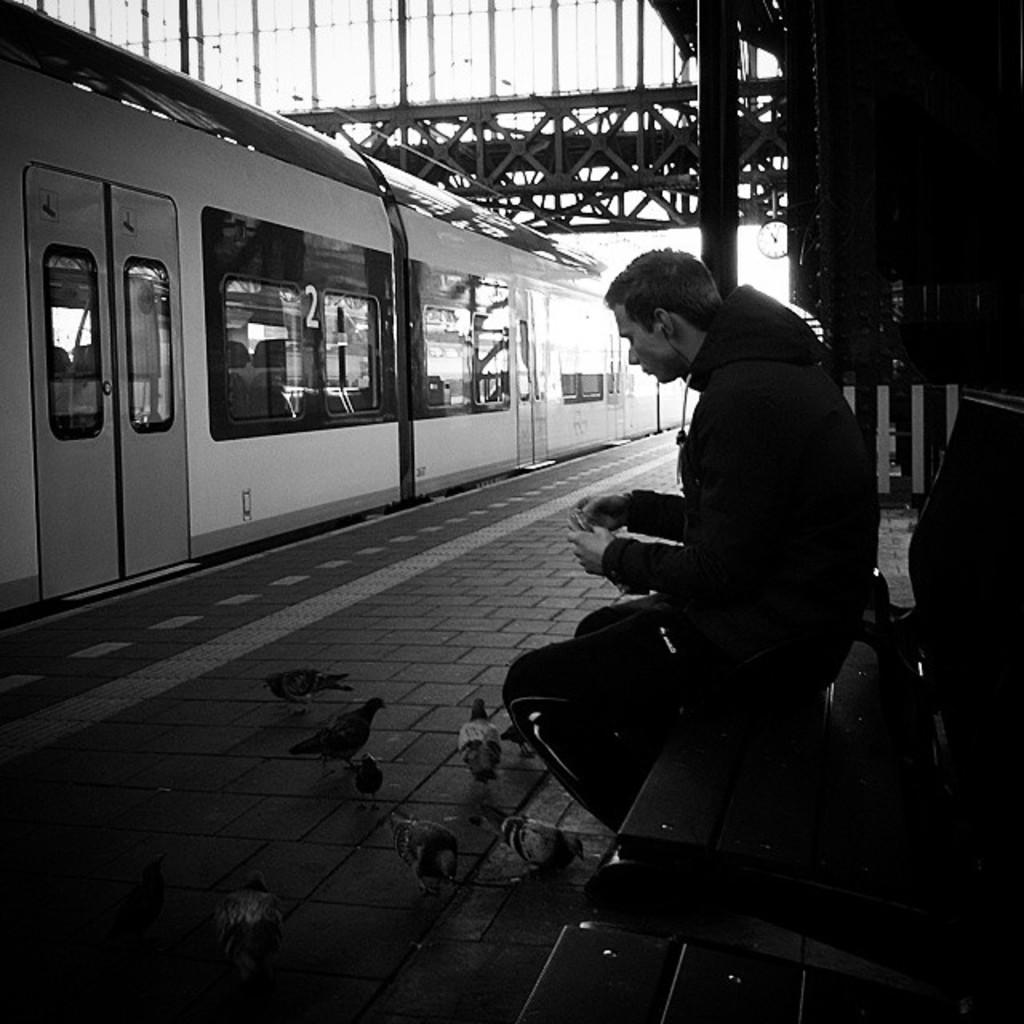Please provide a concise description of this image. This is a black and white image and here we can see a person wearing a coat and there are earphones and holding a mobile in his hands and sitting on the bench. In the background, there is a train and we can see a bridge, a clock, a pole and there is another bench. At the bottom, there are birds on the floor. 